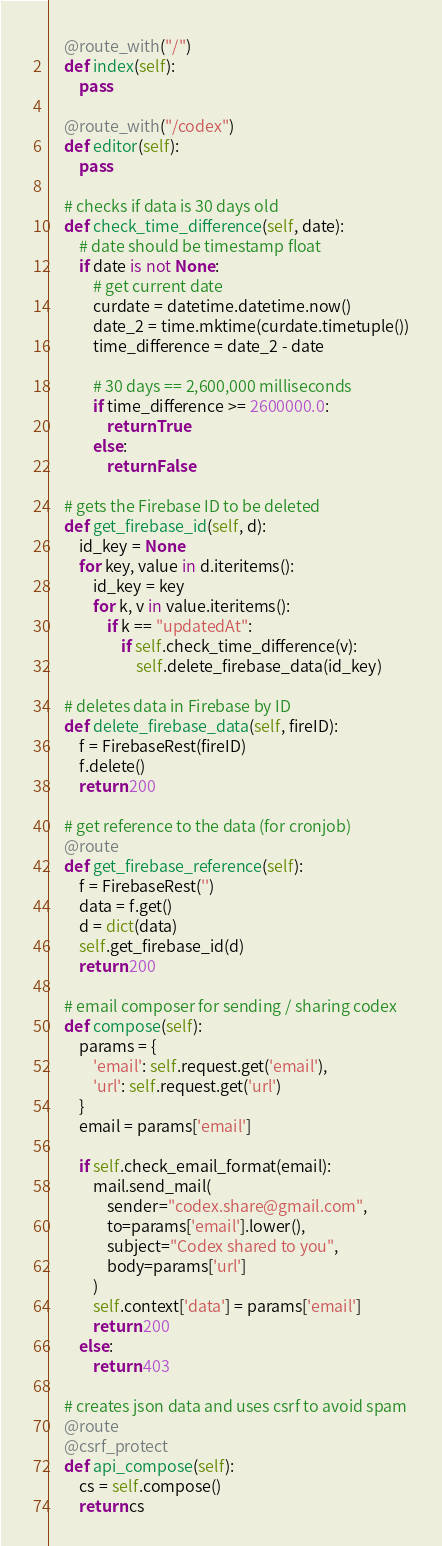<code> <loc_0><loc_0><loc_500><loc_500><_Python_>    @route_with("/")
    def index(self):
        pass

    @route_with("/codex")
    def editor(self):
        pass

    # checks if data is 30 days old
    def check_time_difference(self, date):
        # date should be timestamp float
        if date is not None:
            # get current date
            curdate = datetime.datetime.now()
            date_2 = time.mktime(curdate.timetuple())
            time_difference = date_2 - date

            # 30 days == 2,600,000 milliseconds
            if time_difference >= 2600000.0:
                return True
            else:
                return False

    # gets the Firebase ID to be deleted
    def get_firebase_id(self, d):
        id_key = None
        for key, value in d.iteritems():
            id_key = key
            for k, v in value.iteritems():
                if k == "updatedAt":
                    if self.check_time_difference(v):
                        self.delete_firebase_data(id_key)

    # deletes data in Firebase by ID
    def delete_firebase_data(self, fireID):
        f = FirebaseRest(fireID)
        f.delete()
        return 200

    # get reference to the data (for cronjob)
    @route
    def get_firebase_reference(self):
        f = FirebaseRest('')
        data = f.get()
        d = dict(data)
        self.get_firebase_id(d)
        return 200

    # email composer for sending / sharing codex
    def compose(self):
        params = {
            'email': self.request.get('email'),
            'url': self.request.get('url')
        }
        email = params['email']

        if self.check_email_format(email):
            mail.send_mail(
                sender="codex.share@gmail.com",
                to=params['email'].lower(),
                subject="Codex shared to you",
                body=params['url']
            )
            self.context['data'] = params['email']
            return 200
        else:
            return 403

    # creates json data and uses csrf to avoid spam
    @route
    @csrf_protect
    def api_compose(self):
        cs = self.compose()
        return cs
</code> 